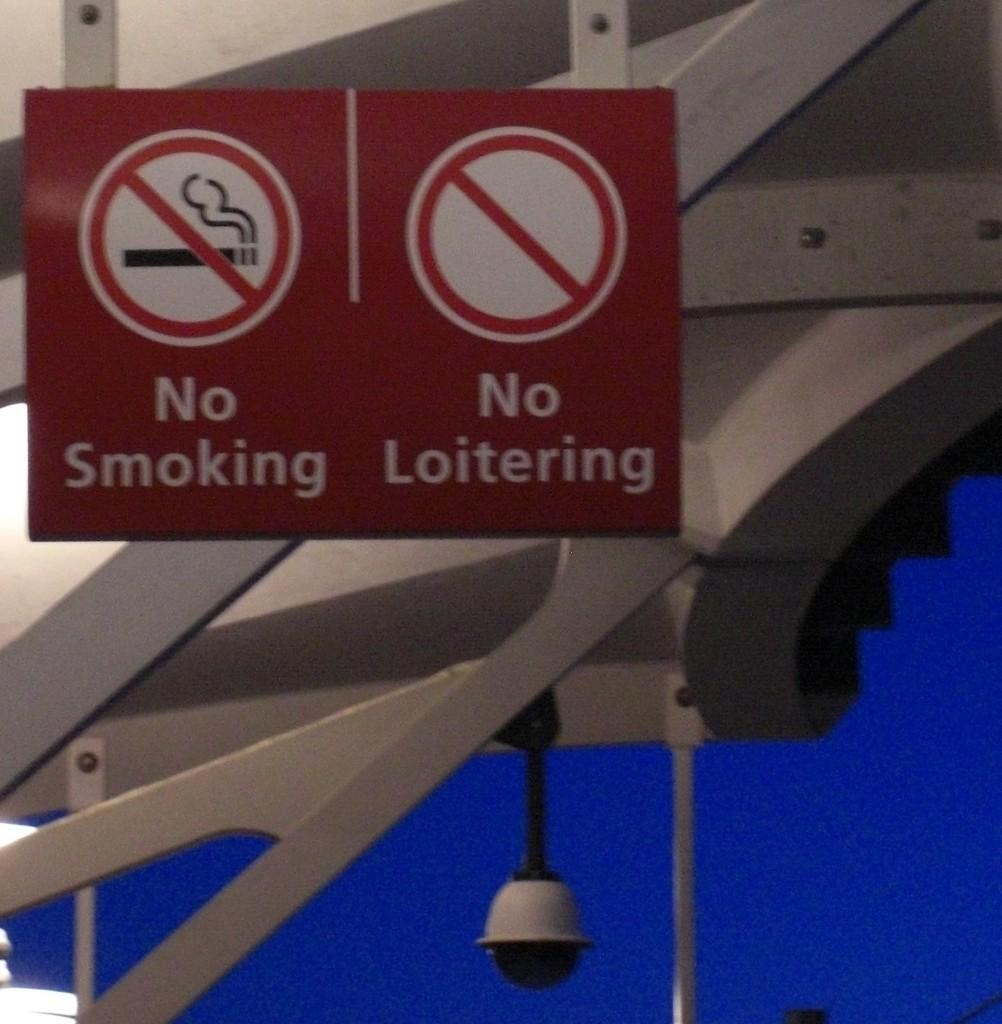<image>
Describe the image concisely. Twp red signs for no smoking or loitering hanging on the structure. 